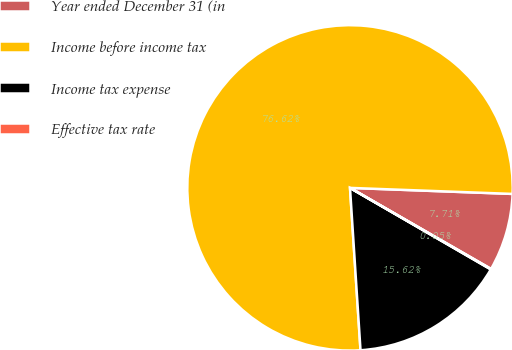<chart> <loc_0><loc_0><loc_500><loc_500><pie_chart><fcel>Year ended December 31 (in<fcel>Income before income tax<fcel>Income tax expense<fcel>Effective tax rate<nl><fcel>7.71%<fcel>76.62%<fcel>15.62%<fcel>0.05%<nl></chart> 